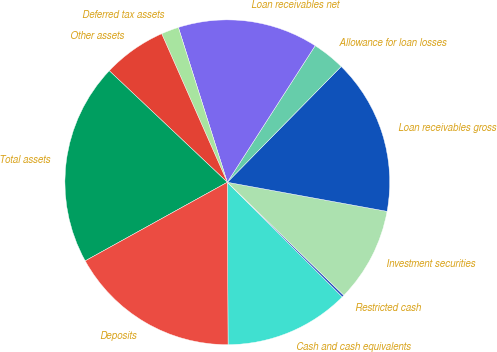Convert chart. <chart><loc_0><loc_0><loc_500><loc_500><pie_chart><fcel>Cash and cash equivalents<fcel>Restricted cash<fcel>Investment securities<fcel>Loan receivables gross<fcel>Allowance for loan losses<fcel>Loan receivables net<fcel>Deferred tax assets<fcel>Other assets<fcel>Total assets<fcel>Deposits<nl><fcel>12.45%<fcel>0.22%<fcel>9.39%<fcel>15.5%<fcel>3.27%<fcel>13.97%<fcel>1.75%<fcel>6.33%<fcel>20.09%<fcel>17.03%<nl></chart> 